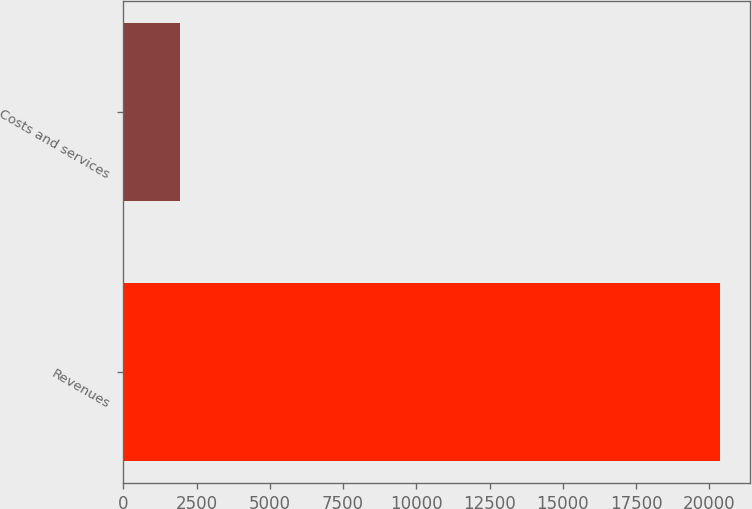<chart> <loc_0><loc_0><loc_500><loc_500><bar_chart><fcel>Revenues<fcel>Costs and services<nl><fcel>20361<fcel>1944<nl></chart> 